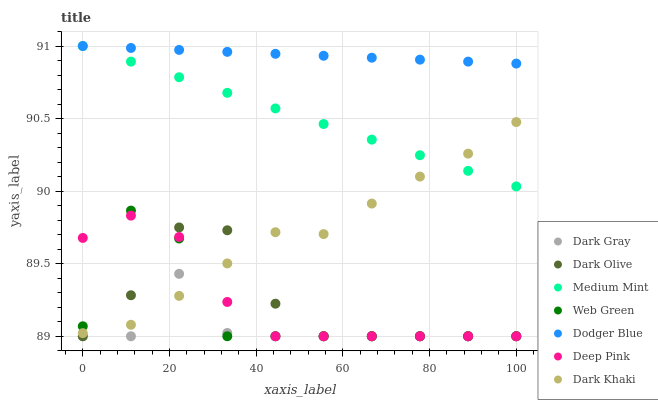Does Dark Gray have the minimum area under the curve?
Answer yes or no. Yes. Does Dodger Blue have the maximum area under the curve?
Answer yes or no. Yes. Does Dark Khaki have the minimum area under the curve?
Answer yes or no. No. Does Dark Khaki have the maximum area under the curve?
Answer yes or no. No. Is Dodger Blue the smoothest?
Answer yes or no. Yes. Is Web Green the roughest?
Answer yes or no. Yes. Is Dark Khaki the smoothest?
Answer yes or no. No. Is Dark Khaki the roughest?
Answer yes or no. No. Does Deep Pink have the lowest value?
Answer yes or no. Yes. Does Dark Khaki have the lowest value?
Answer yes or no. No. Does Dodger Blue have the highest value?
Answer yes or no. Yes. Does Dark Khaki have the highest value?
Answer yes or no. No. Is Dark Gray less than Dodger Blue?
Answer yes or no. Yes. Is Dodger Blue greater than Dark Gray?
Answer yes or no. Yes. Does Medium Mint intersect Dodger Blue?
Answer yes or no. Yes. Is Medium Mint less than Dodger Blue?
Answer yes or no. No. Is Medium Mint greater than Dodger Blue?
Answer yes or no. No. Does Dark Gray intersect Dodger Blue?
Answer yes or no. No. 